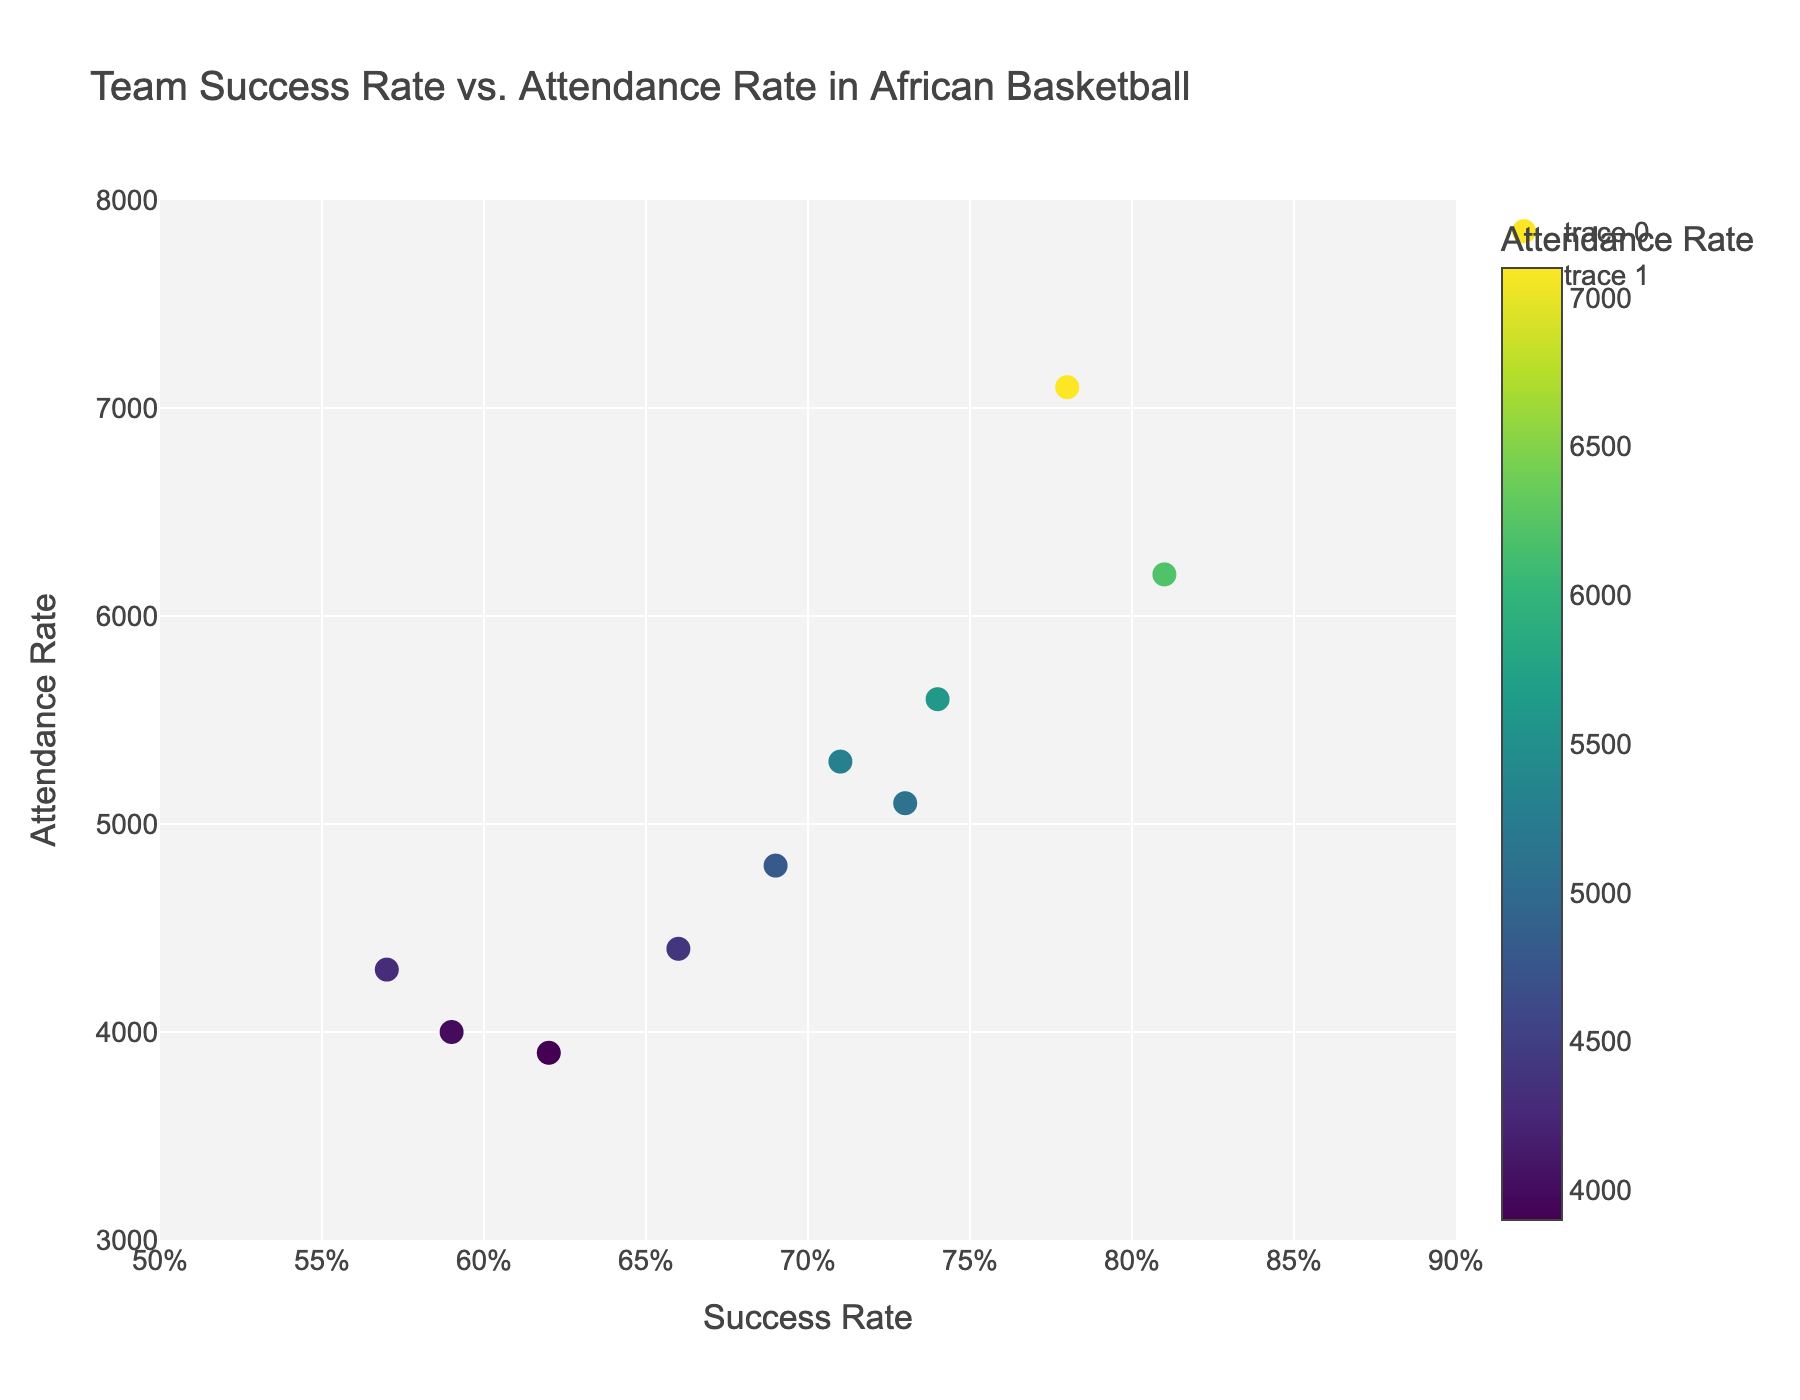What's the title of the figure? The title is usually at the top of the figure and provides an overview of what the plot is about. In this case, it states, "Team Success Rate vs. Attendance Rate in African Basketball."
Answer: Team Success Rate vs. Attendance Rate in African Basketball What is the range of attendance rates displayed in the figure? The y-axis represents the attendance rates, and the range can be observed from the lowest to the highest point along this axis. The y-axis starts at 3000 and ends at 8000.
Answer: 3000 to 8000 Which team has the highest attendance rate? By looking at the y-axis, find the data point that is at the highest position. The team corresponding to this point is Petro de Luanda.
Answer: Petro de Luanda Which team has the lowest success rate? The x-axis represents the success rates. Find the data point that is furthest to the left, which corresponds to Stade Malien.
Answer: Stade Malien Which teams have an attendance rate above 6000? Observe all data points above the y-axis value of 6000. The teams corresponding to these points are Petro de Luanda and Zamalek SC.
Answer: Petro de Luanda, Zamalek SC What is the average success rate of all the teams? Sum up all the success rates and divide by the number of teams. (0.78 + 0.81 + 0.69 + 0.57 + 0.74 + 0.62 + 0.73 + 0.66 + 0.71 + 0.59) / 10 = 6.9 / 10 = 0.69
Answer: 0.69 Which team has the largest error margin in attendance rate? Identify the team with the largest error bar vertically. Petro de Luanda has the largest error margin for attendance with 400.
Answer: Petro de Luanda How does the attendance rate of AS Salé compare to that of Cape Town Tigers? Look at the y-axis positions of both teams' data points. AS Salé has an attendance rate of 4800, while Cape Town Tigers has 3900.
Answer: AS Salé has a higher attendance rate than Cape Town Tigers Which teams have both a success rate higher than 0.7 and an attendance rate higher than 5000? Identify data points that both lie to the right of x-axis 0.7 and above y-axis 5000. The teams are Petro de Luanda, Zamalek SC, and Union Sportive Monastirienne.
Answer: Petro de Luanda, Zamalek SC, Union Sportive Monastirienne Do any teams have both a low attendance rate and a low success rate? Identify data points that are both low on the y-axis (below 4500) and x-axis (below 0.65). Cape Town Tigers, Stade Malien, and FAP fit this criterion.
Answer: Cape Town Tigers, Stade Malien, FAP 